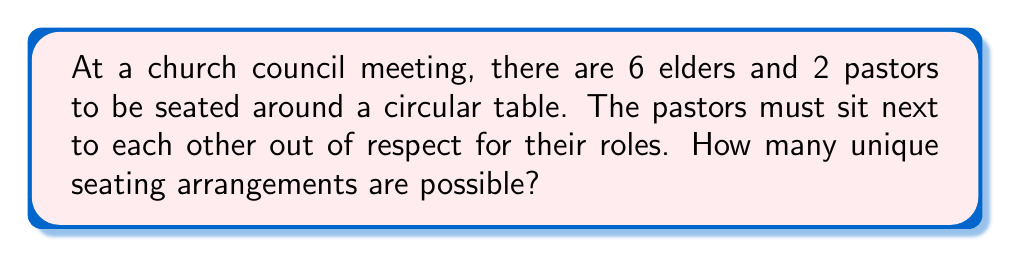Solve this math problem. Let's approach this step-by-step:

1) First, we consider the pastors as a single unit. So now we have 7 units to arrange (6 elders and 1 pastor unit).

2) For a circular arrangement of $n$ distinct objects, there are $(n-1)!$ unique arrangements. This is because we can fix the position of one object and arrange the rest.

3) So, for our 7 units, we have $6! = 720$ arrangements.

4) Now, for each of these arrangements, the 2 pastors can swap their positions. This doubles our possibilities.

5) Therefore, the total number of arrangements is:

   $$ 6! \times 2 = 720 \times 2 = 1440 $$

6) However, we're not done yet. Remember that the pastors can also be seated in 2 different orientations relative to the table (facing inward or outward).

7) This again doubles our possibilities:

   $$ 1440 \times 2 = 2880 $$

Thus, the total number of unique seating arrangements is 2880.
Answer: 2880 